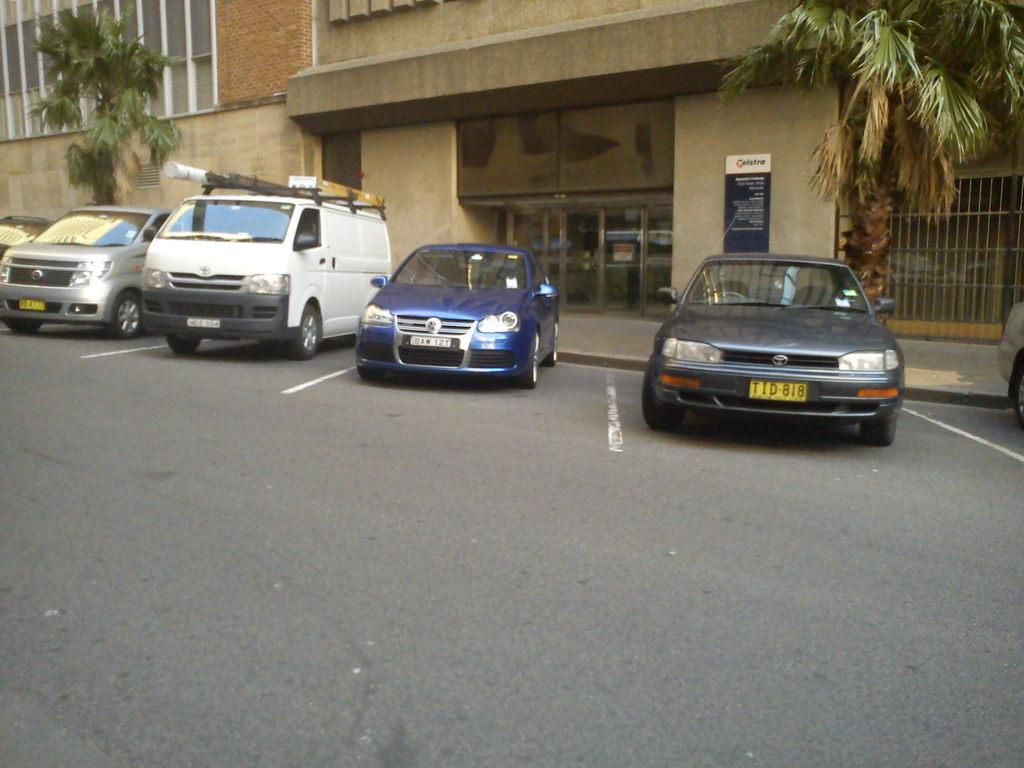What can be seen parked on the side of the road in the image? There are vehicles parked on the side of the road in the image. What is located behind the parked vehicles? The vehicles are in front of a building. What is on the building in the image? The building has a board. What type of vegetation is present on the footpath? There are trees on the footpath. Can you tell me how many brothers are standing next to the trees on the footpath? There is no mention of any brothers in the image, and therefore we cannot determine their presence or number. What type of whistle can be heard coming from the building in the image? There is no indication of any sound, including a whistle, in the image. 